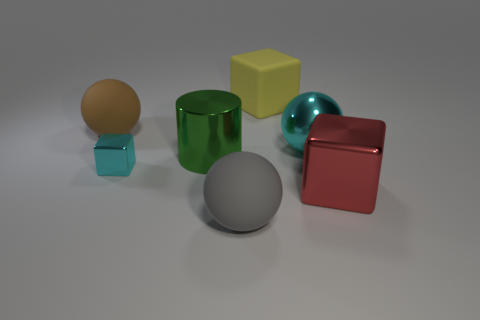What material is the large green cylinder to the left of the gray rubber thing?
Provide a succinct answer. Metal. What is the big brown sphere made of?
Give a very brief answer. Rubber. What material is the ball to the left of the block left of the large metal thing that is to the left of the big yellow matte block?
Your answer should be compact. Rubber. Is there any other thing that is made of the same material as the cylinder?
Your answer should be very brief. Yes. There is a green object; does it have the same size as the cyan block that is in front of the shiny ball?
Offer a terse response. No. How many things are shiny objects that are behind the red metal cube or matte objects that are on the left side of the big yellow block?
Make the answer very short. 5. There is a matte object that is in front of the brown matte sphere; what color is it?
Provide a short and direct response. Gray. Is there a green cylinder that is in front of the big block that is in front of the brown object?
Keep it short and to the point. No. Are there fewer green objects than large blue metal spheres?
Your response must be concise. No. There is a sphere that is right of the rubber thing behind the large brown matte object; what is it made of?
Offer a terse response. Metal. 